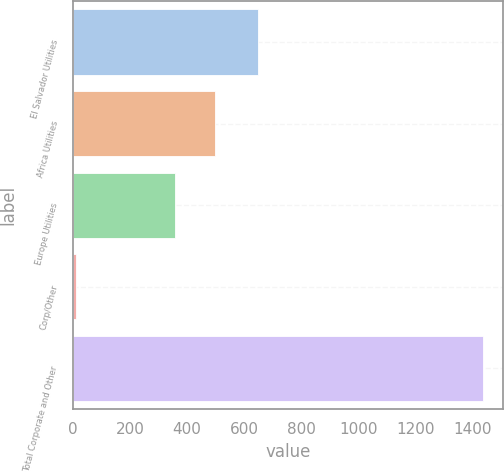Convert chart to OTSL. <chart><loc_0><loc_0><loc_500><loc_500><bar_chart><fcel>El Salvador Utilities<fcel>Africa Utilities<fcel>Europe Utilities<fcel>Corp/Other<fcel>Total Corporate and Other<nl><fcel>647<fcel>498.5<fcel>356<fcel>10<fcel>1435<nl></chart> 